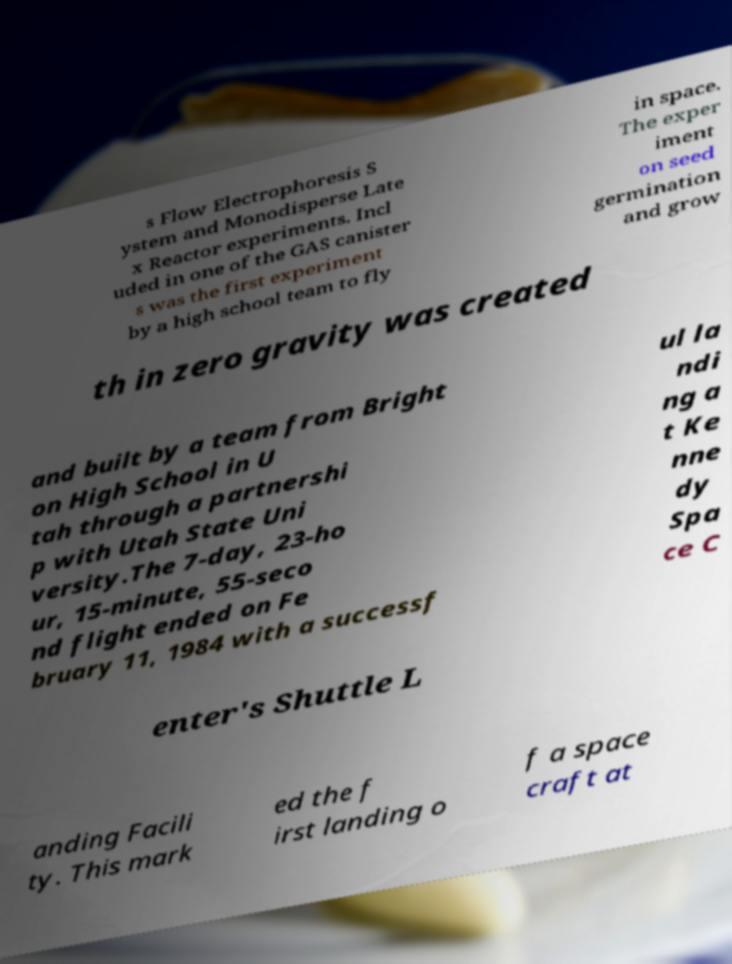Can you accurately transcribe the text from the provided image for me? s Flow Electrophoresis S ystem and Monodisperse Late x Reactor experiments. Incl uded in one of the GAS canister s was the first experiment by a high school team to fly in space. The exper iment on seed germination and grow th in zero gravity was created and built by a team from Bright on High School in U tah through a partnershi p with Utah State Uni versity.The 7-day, 23-ho ur, 15-minute, 55-seco nd flight ended on Fe bruary 11, 1984 with a successf ul la ndi ng a t Ke nne dy Spa ce C enter's Shuttle L anding Facili ty. This mark ed the f irst landing o f a space craft at 